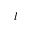Convert formula to latex. <formula><loc_0><loc_0><loc_500><loc_500>l</formula> 